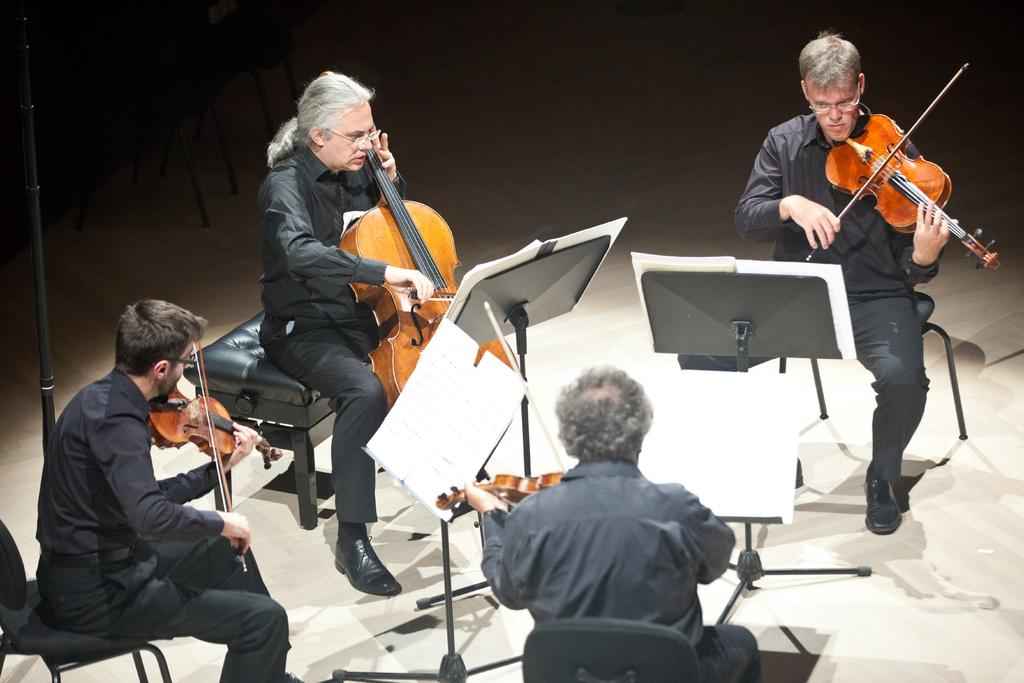How many people are in the image? There are four men in the image. What are the men doing in the image? The men are sitting in an order and playing the violin. What can be seen in front of the men? There are music notes in front of the men. What type of button can be seen on the violin in the image? There are no buttons visible on the violins in the image. What observation can be made about the pump in the image? There is no pump present in the image. 